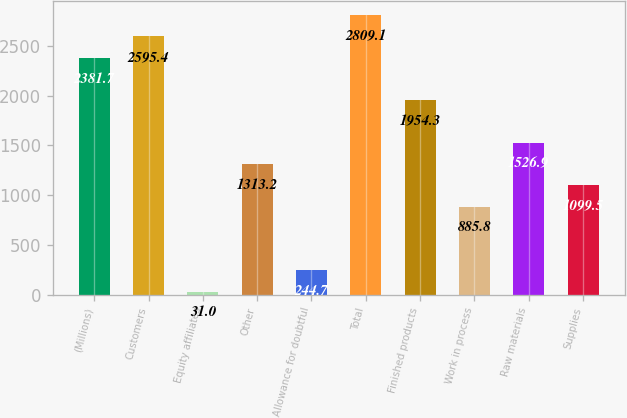Convert chart. <chart><loc_0><loc_0><loc_500><loc_500><bar_chart><fcel>(Millions)<fcel>Customers<fcel>Equity affiliates<fcel>Other<fcel>Allowance for doubtful<fcel>Total<fcel>Finished products<fcel>Work in process<fcel>Raw materials<fcel>Supplies<nl><fcel>2381.7<fcel>2595.4<fcel>31<fcel>1313.2<fcel>244.7<fcel>2809.1<fcel>1954.3<fcel>885.8<fcel>1526.9<fcel>1099.5<nl></chart> 